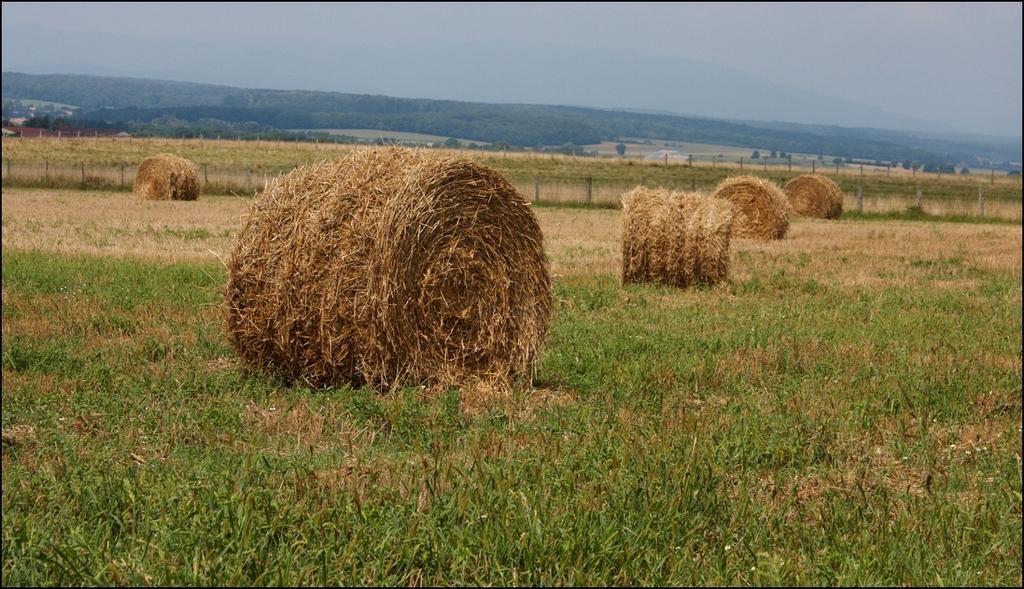Can you describe this image briefly? Here we can see grass, fence, and trees. In the background there is sky. 